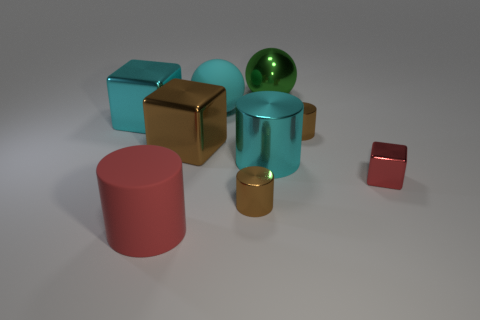Is the size of the cyan object that is on the left side of the cyan ball the same as the green ball behind the big rubber cylinder?
Give a very brief answer. Yes. What size is the brown metal cylinder left of the large cyan metal cylinder?
Give a very brief answer. Small. What size is the metallic cube to the left of the big matte thing in front of the big cyan shiny block?
Your answer should be very brief. Large. There is a green thing that is the same size as the cyan matte sphere; what material is it?
Make the answer very short. Metal. Are there any tiny red metal objects in front of the red metallic object?
Ensure brevity in your answer.  No. Is the number of large cyan shiny objects that are on the left side of the large red cylinder the same as the number of big cyan balls?
Offer a terse response. Yes. There is a brown metal thing that is the same size as the cyan metallic block; what shape is it?
Your answer should be very brief. Cube. What is the small red block made of?
Make the answer very short. Metal. What is the color of the metallic cube that is on the left side of the green metallic sphere and to the right of the large rubber cylinder?
Provide a succinct answer. Brown. Is the number of big cylinders that are behind the red block the same as the number of shiny spheres that are in front of the big cyan cylinder?
Your response must be concise. No. 